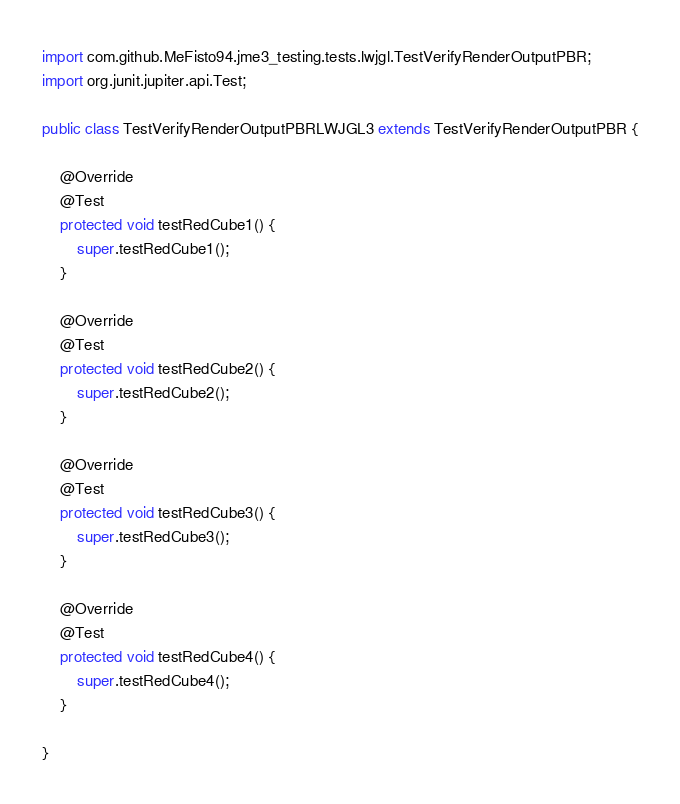Convert code to text. <code><loc_0><loc_0><loc_500><loc_500><_Java_>import com.github.MeFisto94.jme3_testing.tests.lwjgl.TestVerifyRenderOutputPBR;
import org.junit.jupiter.api.Test;

public class TestVerifyRenderOutputPBRLWJGL3 extends TestVerifyRenderOutputPBR {

    @Override
    @Test
    protected void testRedCube1() {
        super.testRedCube1();
    }

    @Override
    @Test
    protected void testRedCube2() {
        super.testRedCube2();
    }

    @Override
    @Test
    protected void testRedCube3() {
        super.testRedCube3();
    }

    @Override
    @Test
    protected void testRedCube4() {
        super.testRedCube4();
    }

}
</code> 